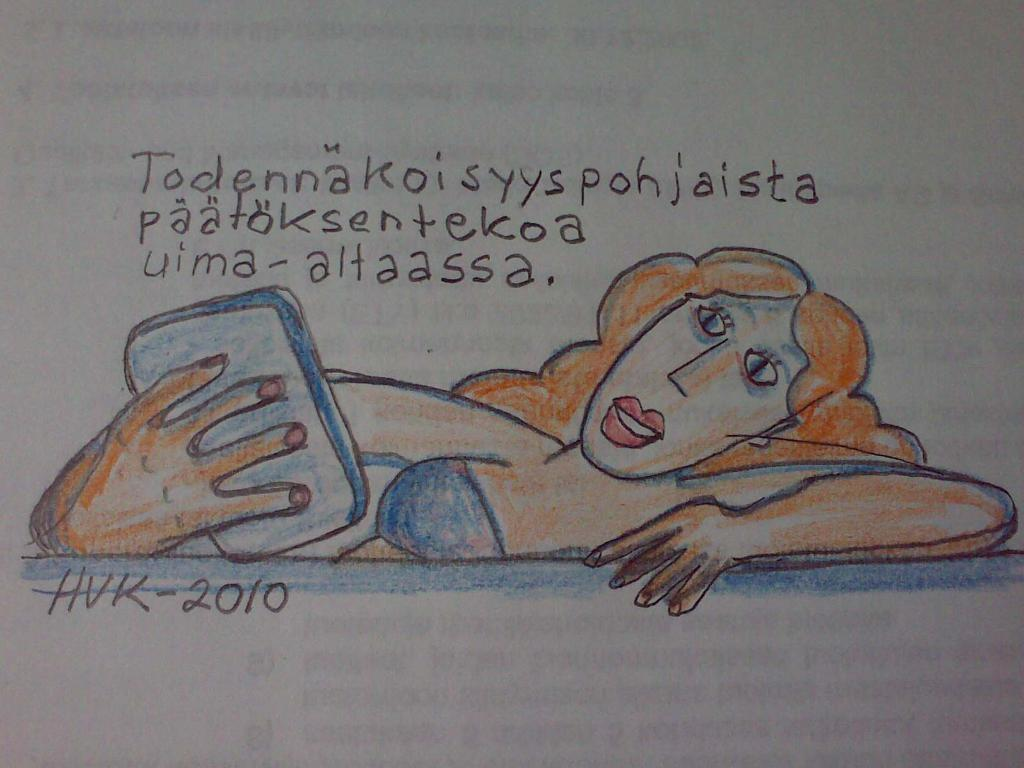What type of artwork is depicted in the image? The image is a drawing. Who is the main subject in the drawing? There is a woman in the center of the drawing. What is the woman holding in the drawing? The woman is holding an object. Can you describe the text above the woman in the drawing? The text is on a paper above the woman. How many fingers does the woman have on her left hand in the drawing? The image does not provide enough detail to determine the number of fingers on the woman's left hand. 